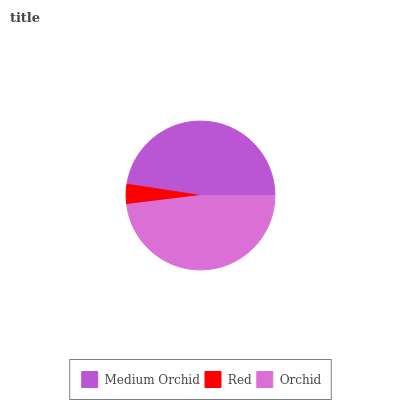Is Red the minimum?
Answer yes or no. Yes. Is Orchid the maximum?
Answer yes or no. Yes. Is Orchid the minimum?
Answer yes or no. No. Is Red the maximum?
Answer yes or no. No. Is Orchid greater than Red?
Answer yes or no. Yes. Is Red less than Orchid?
Answer yes or no. Yes. Is Red greater than Orchid?
Answer yes or no. No. Is Orchid less than Red?
Answer yes or no. No. Is Medium Orchid the high median?
Answer yes or no. Yes. Is Medium Orchid the low median?
Answer yes or no. Yes. Is Orchid the high median?
Answer yes or no. No. Is Orchid the low median?
Answer yes or no. No. 